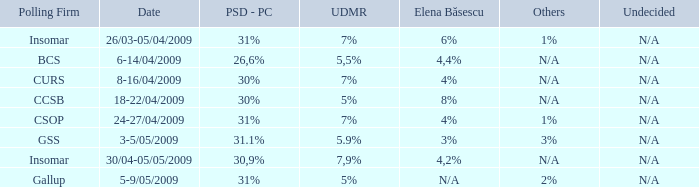What is the elena basescu when the poling firm of gallup? N/A. 